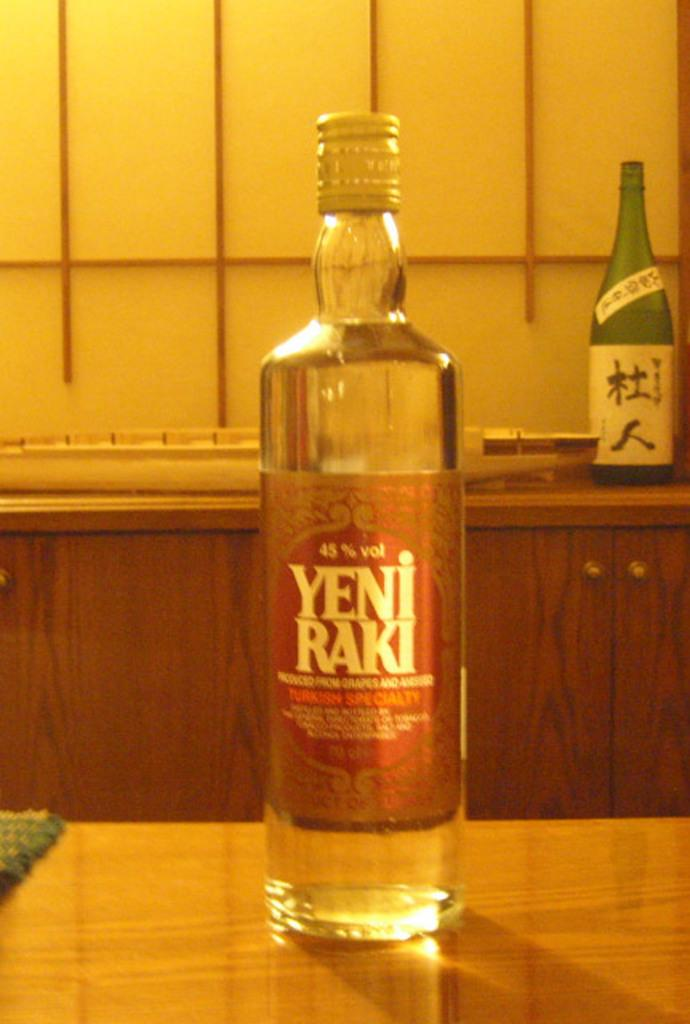What is on the table in the image? There is a wine bottle on a table in the image. Can you describe the background of the image? There is another wine bottle in the background of the image. What type of cream is being used in the religious ceremony depicted in the image? There is no religious ceremony or cream present in the image; it only features two wine bottles. 